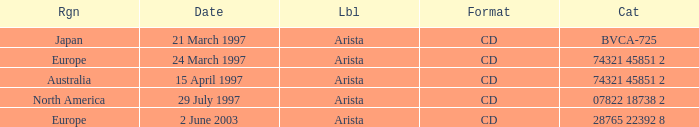What's listed for the Label with a Date of 29 July 1997? Arista. Would you mind parsing the complete table? {'header': ['Rgn', 'Date', 'Lbl', 'Format', 'Cat'], 'rows': [['Japan', '21 March 1997', 'Arista', 'CD', 'BVCA-725'], ['Europe', '24 March 1997', 'Arista', 'CD', '74321 45851 2'], ['Australia', '15 April 1997', 'Arista', 'CD', '74321 45851 2'], ['North America', '29 July 1997', 'Arista', 'CD', '07822 18738 2'], ['Europe', '2 June 2003', 'Arista', 'CD', '28765 22392 8']]} 